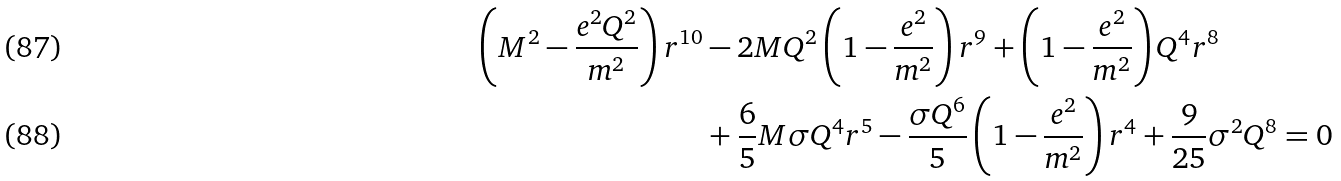Convert formula to latex. <formula><loc_0><loc_0><loc_500><loc_500>\left ( M ^ { 2 } - \frac { e ^ { 2 } Q ^ { 2 } } { m ^ { 2 } } \right ) r ^ { 1 0 } & - 2 M Q ^ { 2 } \left ( 1 - \frac { e ^ { 2 } } { m ^ { 2 } } \right ) r ^ { 9 } + \left ( 1 - \frac { e ^ { 2 } } { m ^ { 2 } } \right ) Q ^ { 4 } r ^ { 8 } \\ & + \frac { 6 } { 5 } M \sigma Q ^ { 4 } r ^ { 5 } - \frac { \sigma Q ^ { 6 } } { 5 } \left ( 1 - \frac { e ^ { 2 } } { m ^ { 2 } } \right ) r ^ { 4 } + \frac { 9 } { 2 5 } \sigma ^ { 2 } Q ^ { 8 } = 0</formula> 